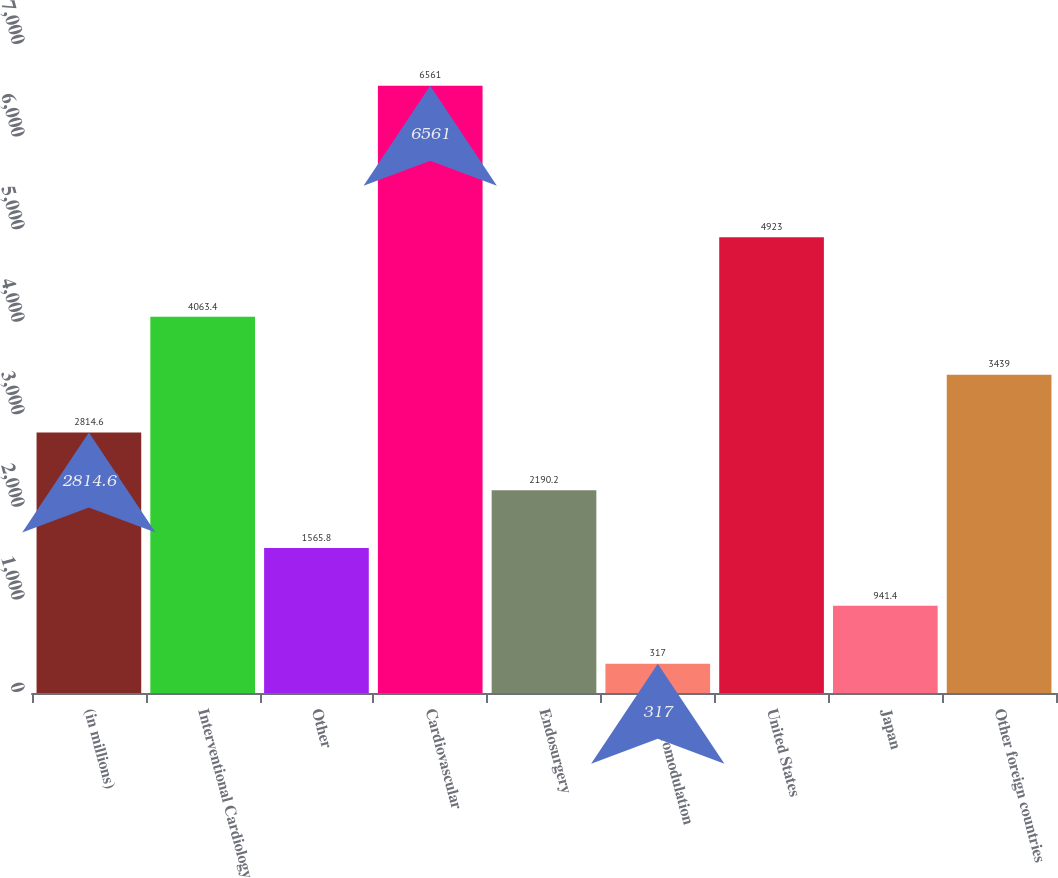Convert chart to OTSL. <chart><loc_0><loc_0><loc_500><loc_500><bar_chart><fcel>(in millions)<fcel>Interventional Cardiology<fcel>Other<fcel>Cardiovascular<fcel>Endosurgery<fcel>Neuromodulation<fcel>United States<fcel>Japan<fcel>Other foreign countries<nl><fcel>2814.6<fcel>4063.4<fcel>1565.8<fcel>6561<fcel>2190.2<fcel>317<fcel>4923<fcel>941.4<fcel>3439<nl></chart> 